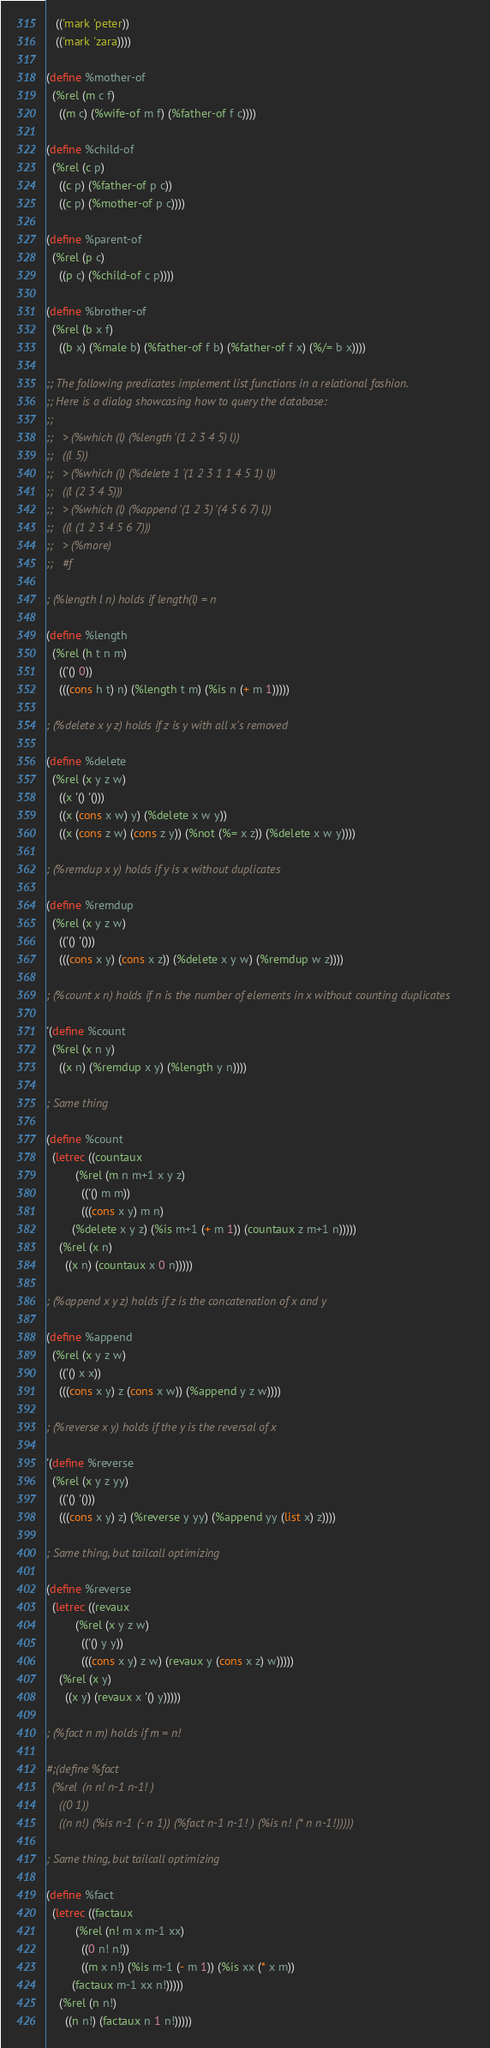Convert code to text. <code><loc_0><loc_0><loc_500><loc_500><_Scheme_>   (('mark 'peter))
   (('mark 'zara))))

(define %mother-of
  (%rel (m c f)
    ((m c) (%wife-of m f) (%father-of f c))))

(define %child-of
  (%rel (c p)
    ((c p) (%father-of p c))
    ((c p) (%mother-of p c))))

(define %parent-of
  (%rel (p c)
    ((p c) (%child-of c p))))

(define %brother-of
  (%rel (b x f)
    ((b x) (%male b) (%father-of f b) (%father-of f x) (%/= b x))))

;; The following predicates implement list functions in a relational fashion.
;; Here is a dialog showcasing how to query the database:
;; 
;;   > (%which (l) (%length '(1 2 3 4 5) l))
;;   ((l 5))
;;   > (%which (l) (%delete 1 '(1 2 3 1 1 4 5 1) l))
;;   ((l (2 3 4 5)))
;;   > (%which (l) (%append '(1 2 3) '(4 5 6 7) l))
;;   ((l (1 2 3 4 5 6 7)))
;;   > (%more)
;;   #f

; (%length l n) holds if length(l) = n

(define %length
  (%rel (h t n m)
    (('() 0))
    (((cons h t) n) (%length t m) (%is n (+ m 1)))))

; (%delete x y z) holds if z is y with all x's removed

(define %delete
  (%rel (x y z w)
    ((x '() '()))
    ((x (cons x w) y) (%delete x w y))
    ((x (cons z w) (cons z y)) (%not (%= x z)) (%delete x w y))))

; (%remdup x y) holds if y is x without duplicates

(define %remdup
  (%rel (x y z w)
    (('() '()))
    (((cons x y) (cons x z)) (%delete x y w) (%remdup w z))))

; (%count x n) holds if n is the number of elements in x without counting duplicates

'(define %count
  (%rel (x n y)
    ((x n) (%remdup x y) (%length y n))))

; Same thing

(define %count
  (letrec ((countaux
	     (%rel (m n m+1 x y z)
	       (('() m m))
	       (((cons x y) m n)
		(%delete x y z) (%is m+1 (+ m 1)) (countaux z m+1 n)))))
    (%rel (x n)
      ((x n) (countaux x 0 n)))))

; (%append x y z) holds if z is the concatenation of x and y

(define %append
  (%rel (x y z w)
    (('() x x))
    (((cons x y) z (cons x w)) (%append y z w))))

; (%reverse x y) holds if the y is the reversal of x

'(define %reverse
  (%rel (x y z yy)
    (('() '()))
    (((cons x y) z) (%reverse y yy) (%append yy (list x) z))))

; Same thing, but tailcall optimizing

(define %reverse
  (letrec ((revaux
	     (%rel (x y z w)
	       (('() y y))
	       (((cons x y) z w) (revaux y (cons x z) w)))))
    (%rel (x y)
      ((x y) (revaux x '() y)))))

; (%fact n m) holds if m = n!

#;(define %fact
  (%rel (n n! n-1 n-1!)
    ((0 1))
    ((n n!) (%is n-1 (- n 1)) (%fact n-1 n-1!) (%is n! (* n n-1!)))))

; Same thing, but tailcall optimizing

(define %fact
  (letrec ((factaux
	     (%rel (n! m x m-1 xx)
	       ((0 n! n!))
	       ((m x n!) (%is m-1 (- m 1)) (%is xx (* x m))
		(factaux m-1 xx n!)))))
    (%rel (n n!)
      ((n n!) (factaux n 1 n!)))))
</code> 